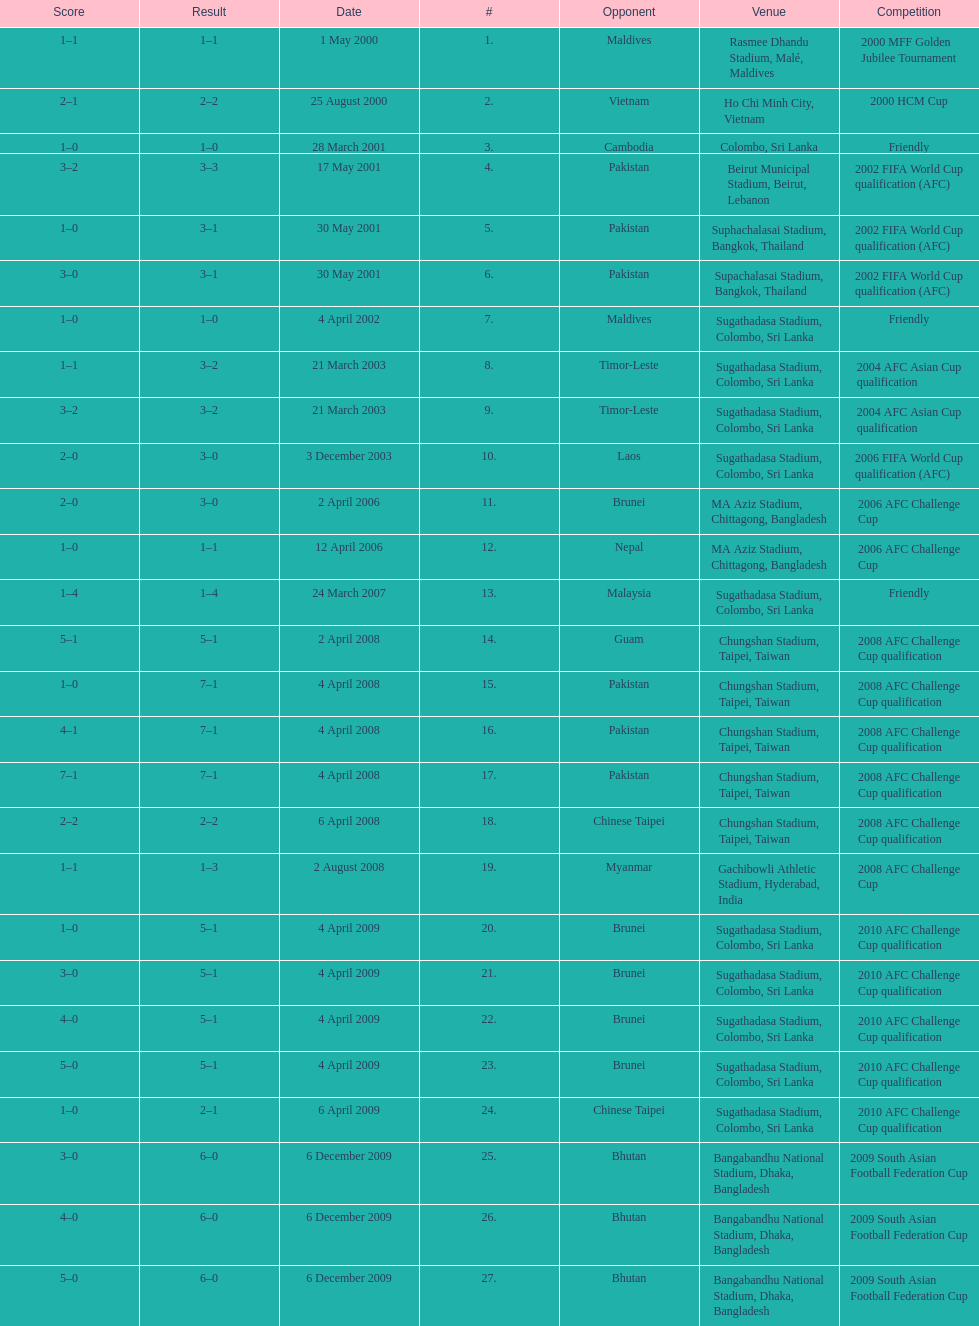What was the total number of goals score in the sri lanka - malaysia game of march 24, 2007? 5. 